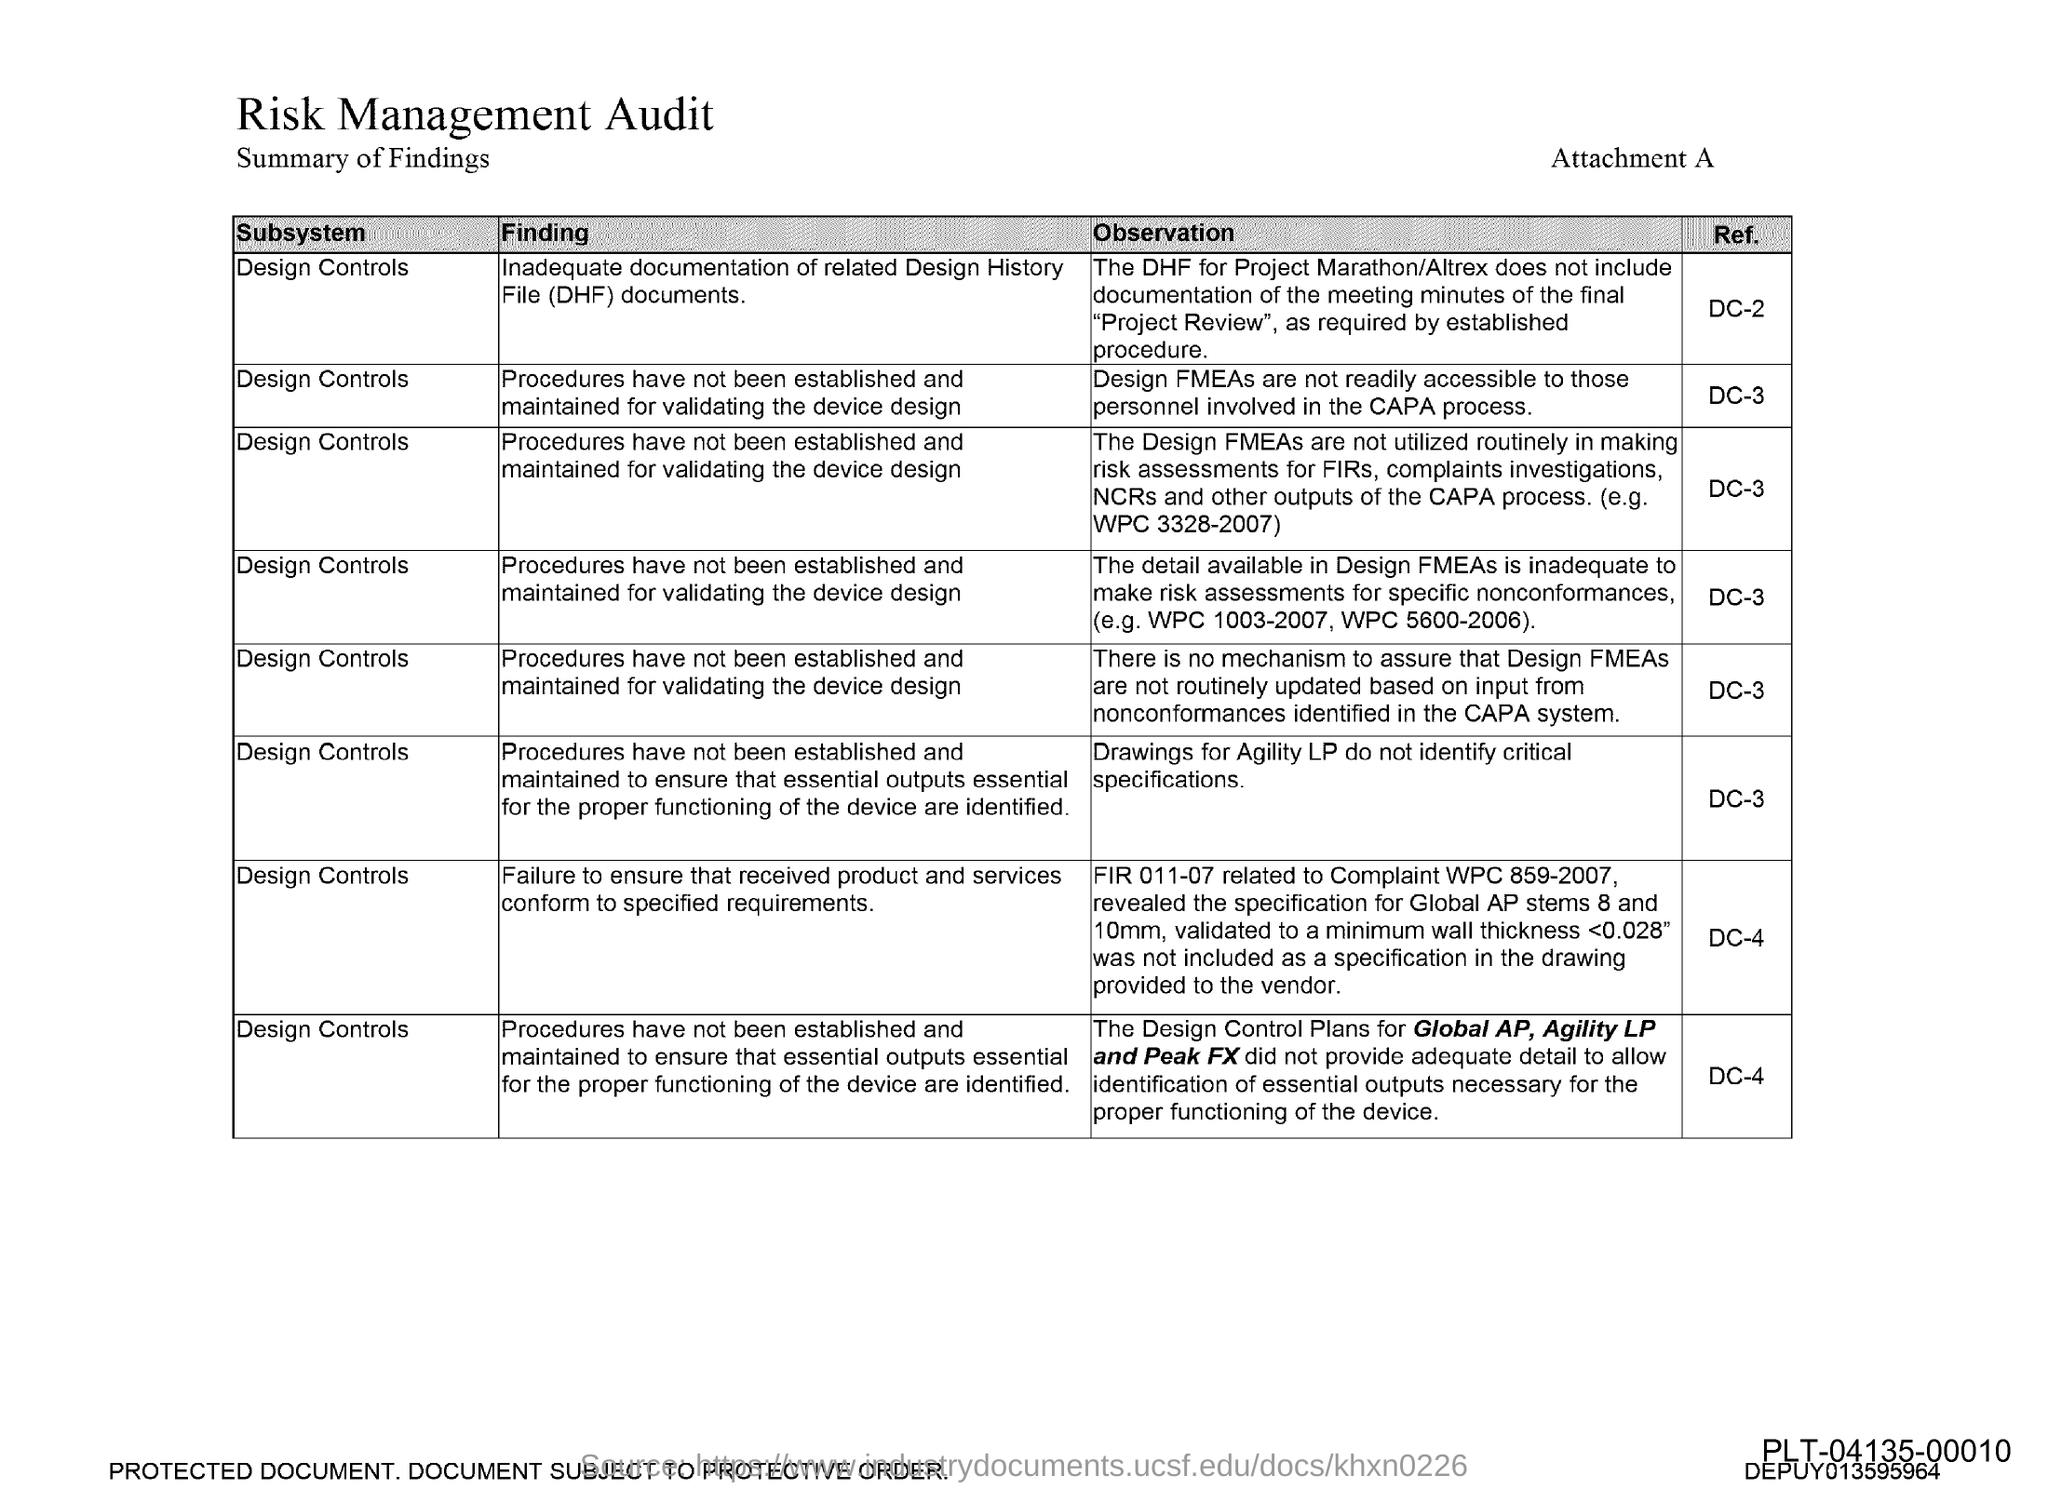Design FMEAs are not readily accessible to those personnel involved in what?
Your answer should be compact. CAPA process. What do Drawings for agility do not identify?
Your answer should be very brief. Critical specifications. 